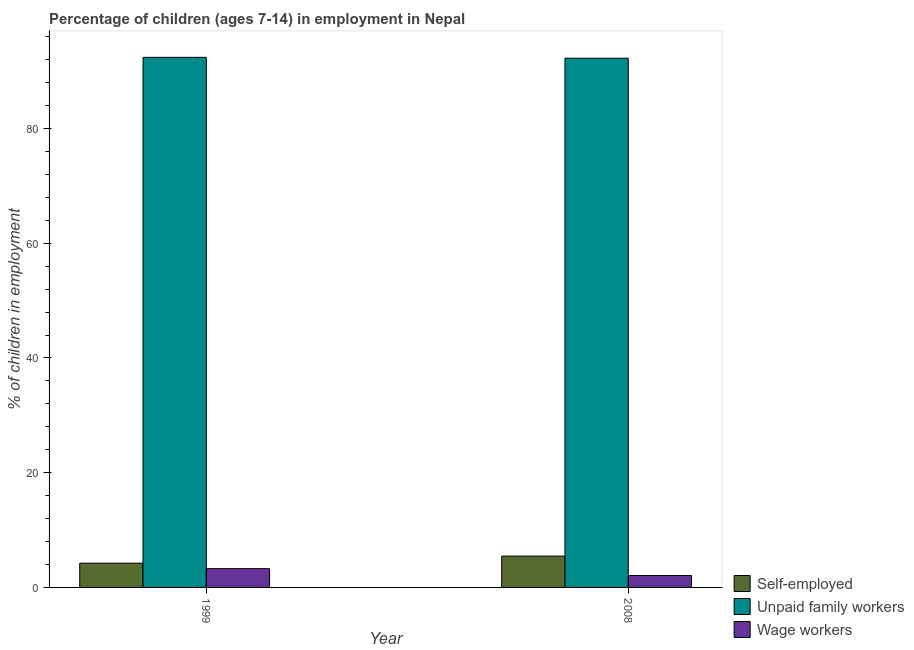Are the number of bars per tick equal to the number of legend labels?
Provide a short and direct response. Yes. How many bars are there on the 1st tick from the left?
Make the answer very short. 3. What is the label of the 1st group of bars from the left?
Make the answer very short. 1999. In how many cases, is the number of bars for a given year not equal to the number of legend labels?
Your response must be concise. 0. What is the percentage of children employed as unpaid family workers in 2008?
Provide a short and direct response. 92.26. Across all years, what is the maximum percentage of children employed as unpaid family workers?
Your answer should be compact. 92.41. Across all years, what is the minimum percentage of children employed as wage workers?
Your response must be concise. 2.08. In which year was the percentage of children employed as wage workers minimum?
Offer a very short reply. 2008. What is the total percentage of children employed as unpaid family workers in the graph?
Provide a succinct answer. 184.67. What is the difference between the percentage of children employed as unpaid family workers in 1999 and that in 2008?
Ensure brevity in your answer.  0.15. What is the difference between the percentage of children employed as wage workers in 1999 and the percentage of children employed as unpaid family workers in 2008?
Ensure brevity in your answer.  1.19. What is the average percentage of children employed as unpaid family workers per year?
Your answer should be compact. 92.34. What is the ratio of the percentage of children employed as unpaid family workers in 1999 to that in 2008?
Your answer should be compact. 1. Is the percentage of self employed children in 1999 less than that in 2008?
Ensure brevity in your answer.  Yes. In how many years, is the percentage of children employed as wage workers greater than the average percentage of children employed as wage workers taken over all years?
Your answer should be very brief. 1. What does the 3rd bar from the left in 2008 represents?
Your response must be concise. Wage workers. What does the 2nd bar from the right in 1999 represents?
Your answer should be compact. Unpaid family workers. Are all the bars in the graph horizontal?
Your answer should be compact. No. What is the difference between two consecutive major ticks on the Y-axis?
Offer a very short reply. 20. Does the graph contain grids?
Keep it short and to the point. No. How many legend labels are there?
Keep it short and to the point. 3. What is the title of the graph?
Offer a terse response. Percentage of children (ages 7-14) in employment in Nepal. What is the label or title of the X-axis?
Offer a terse response. Year. What is the label or title of the Y-axis?
Your response must be concise. % of children in employment. What is the % of children in employment of Self-employed in 1999?
Give a very brief answer. 4.23. What is the % of children in employment in Unpaid family workers in 1999?
Make the answer very short. 92.41. What is the % of children in employment in Wage workers in 1999?
Provide a short and direct response. 3.27. What is the % of children in employment of Self-employed in 2008?
Offer a very short reply. 5.46. What is the % of children in employment of Unpaid family workers in 2008?
Keep it short and to the point. 92.26. What is the % of children in employment in Wage workers in 2008?
Your response must be concise. 2.08. Across all years, what is the maximum % of children in employment of Self-employed?
Your answer should be compact. 5.46. Across all years, what is the maximum % of children in employment in Unpaid family workers?
Ensure brevity in your answer.  92.41. Across all years, what is the maximum % of children in employment of Wage workers?
Your answer should be very brief. 3.27. Across all years, what is the minimum % of children in employment of Self-employed?
Your answer should be compact. 4.23. Across all years, what is the minimum % of children in employment of Unpaid family workers?
Ensure brevity in your answer.  92.26. Across all years, what is the minimum % of children in employment in Wage workers?
Provide a succinct answer. 2.08. What is the total % of children in employment of Self-employed in the graph?
Your answer should be compact. 9.69. What is the total % of children in employment of Unpaid family workers in the graph?
Ensure brevity in your answer.  184.67. What is the total % of children in employment in Wage workers in the graph?
Keep it short and to the point. 5.35. What is the difference between the % of children in employment in Self-employed in 1999 and that in 2008?
Your answer should be very brief. -1.23. What is the difference between the % of children in employment in Unpaid family workers in 1999 and that in 2008?
Give a very brief answer. 0.15. What is the difference between the % of children in employment in Wage workers in 1999 and that in 2008?
Give a very brief answer. 1.19. What is the difference between the % of children in employment in Self-employed in 1999 and the % of children in employment in Unpaid family workers in 2008?
Provide a succinct answer. -88.03. What is the difference between the % of children in employment in Self-employed in 1999 and the % of children in employment in Wage workers in 2008?
Give a very brief answer. 2.15. What is the difference between the % of children in employment in Unpaid family workers in 1999 and the % of children in employment in Wage workers in 2008?
Your answer should be compact. 90.33. What is the average % of children in employment of Self-employed per year?
Your answer should be very brief. 4.84. What is the average % of children in employment of Unpaid family workers per year?
Your answer should be compact. 92.33. What is the average % of children in employment of Wage workers per year?
Your answer should be very brief. 2.67. In the year 1999, what is the difference between the % of children in employment in Self-employed and % of children in employment in Unpaid family workers?
Provide a short and direct response. -88.18. In the year 1999, what is the difference between the % of children in employment in Self-employed and % of children in employment in Wage workers?
Offer a very short reply. 0.96. In the year 1999, what is the difference between the % of children in employment of Unpaid family workers and % of children in employment of Wage workers?
Make the answer very short. 89.14. In the year 2008, what is the difference between the % of children in employment in Self-employed and % of children in employment in Unpaid family workers?
Your answer should be very brief. -86.8. In the year 2008, what is the difference between the % of children in employment of Self-employed and % of children in employment of Wage workers?
Give a very brief answer. 3.38. In the year 2008, what is the difference between the % of children in employment in Unpaid family workers and % of children in employment in Wage workers?
Provide a succinct answer. 90.18. What is the ratio of the % of children in employment in Self-employed in 1999 to that in 2008?
Make the answer very short. 0.77. What is the ratio of the % of children in employment of Wage workers in 1999 to that in 2008?
Make the answer very short. 1.57. What is the difference between the highest and the second highest % of children in employment in Self-employed?
Give a very brief answer. 1.23. What is the difference between the highest and the second highest % of children in employment of Unpaid family workers?
Provide a short and direct response. 0.15. What is the difference between the highest and the second highest % of children in employment of Wage workers?
Give a very brief answer. 1.19. What is the difference between the highest and the lowest % of children in employment of Self-employed?
Give a very brief answer. 1.23. What is the difference between the highest and the lowest % of children in employment in Unpaid family workers?
Make the answer very short. 0.15. What is the difference between the highest and the lowest % of children in employment in Wage workers?
Provide a short and direct response. 1.19. 